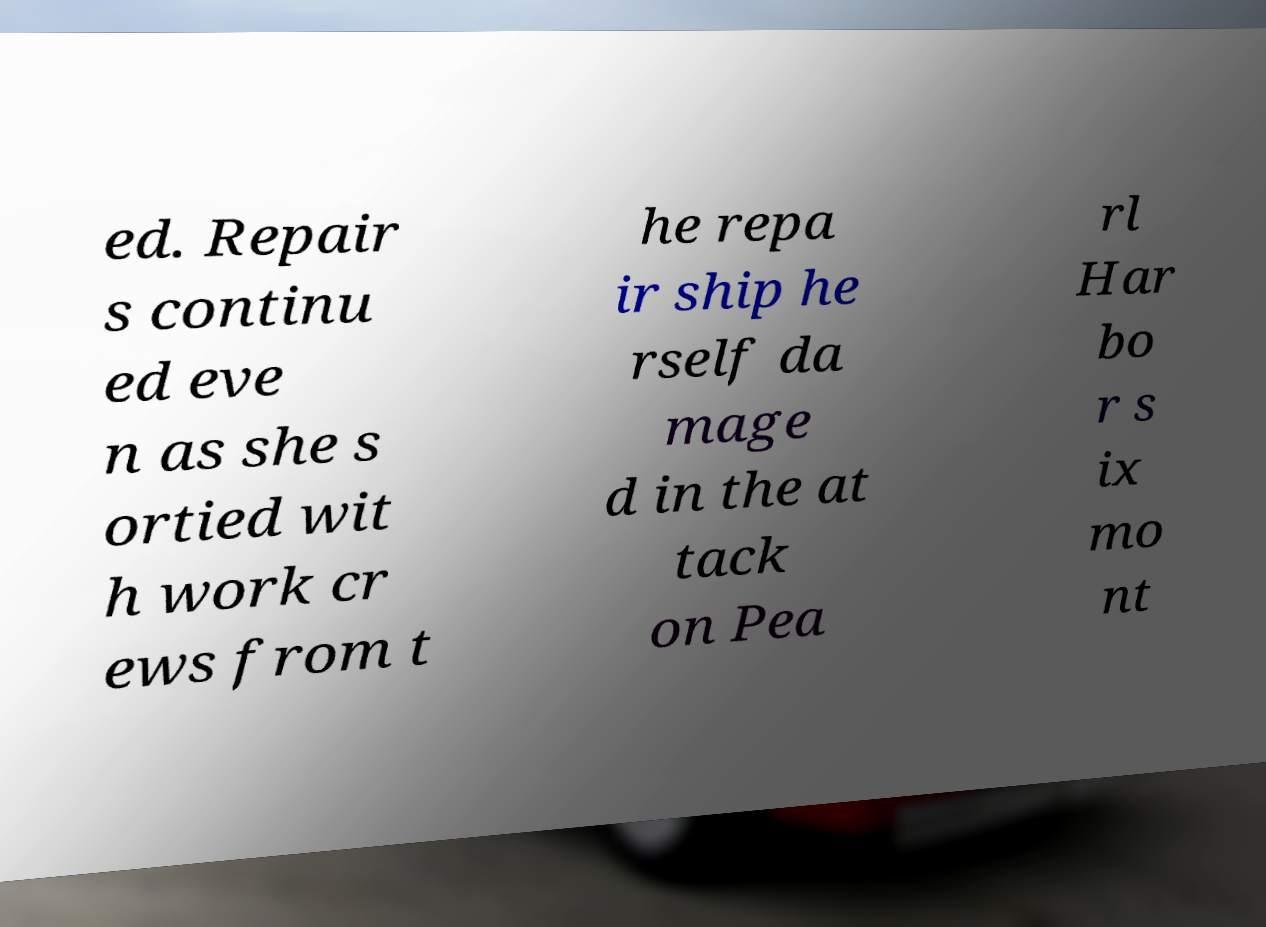There's text embedded in this image that I need extracted. Can you transcribe it verbatim? ed. Repair s continu ed eve n as she s ortied wit h work cr ews from t he repa ir ship he rself da mage d in the at tack on Pea rl Har bo r s ix mo nt 